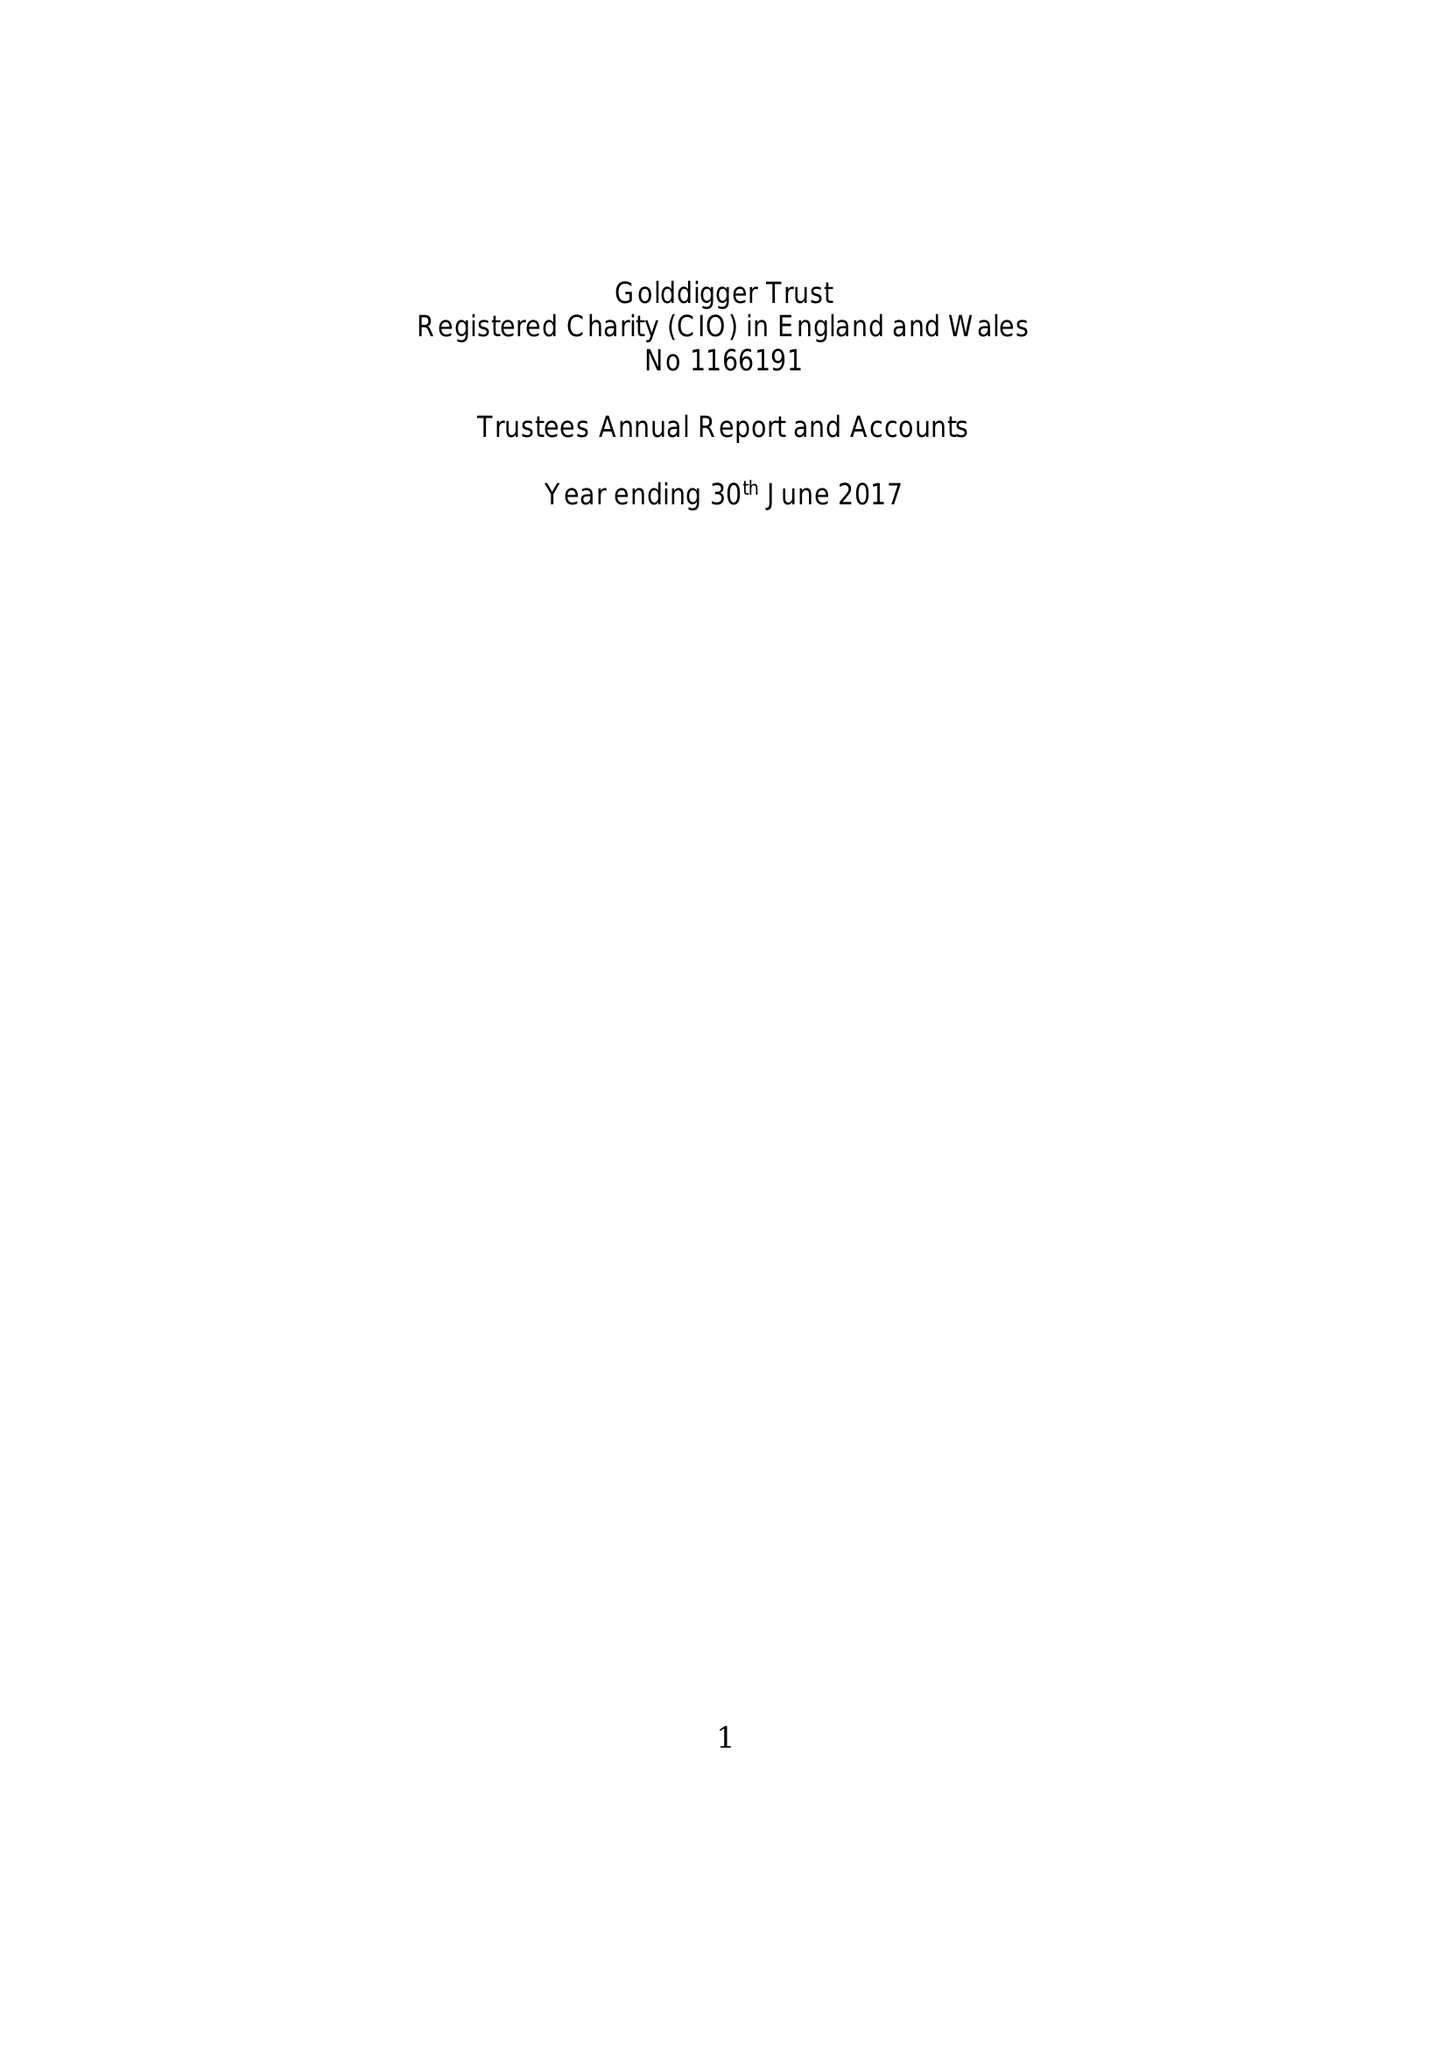What is the value for the charity_number?
Answer the question using a single word or phrase. 1166191 